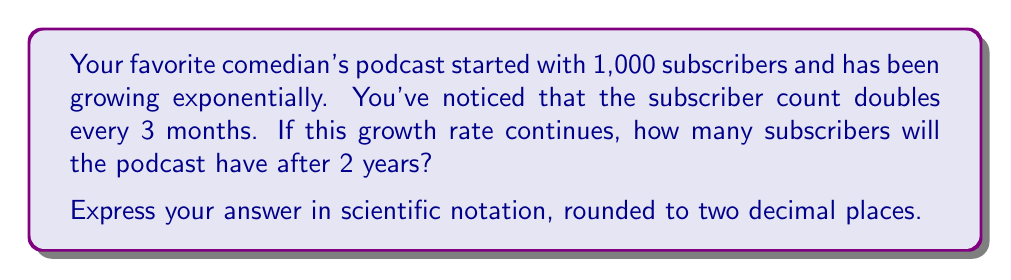What is the answer to this math problem? Let's approach this step-by-step:

1) First, we need to identify the key information:
   - Initial subscribers: 1,000
   - Growth rate: doubles every 3 months
   - Time period: 2 years

2) We can express this as an exponential function:
   $$ S(t) = 1000 \cdot 2^{\frac{t}{3}} $$
   Where $S(t)$ is the number of subscribers after $t$ months.

3) We need to calculate for 2 years, which is 24 months:
   $$ S(24) = 1000 \cdot 2^{\frac{24}{3}} = 1000 \cdot 2^8 $$

4) Let's calculate $2^8$:
   $$ 2^8 = 256 $$

5) Now we can finish the calculation:
   $$ S(24) = 1000 \cdot 256 = 256,000 $$

6) To express this in scientific notation, we move the decimal point 5 places to the left:
   $$ 256,000 = 2.56 \times 10^5 $$

Therefore, after 2 years, the podcast will have approximately $2.56 \times 10^5$ subscribers.
Answer: $2.56 \times 10^5$ subscribers 